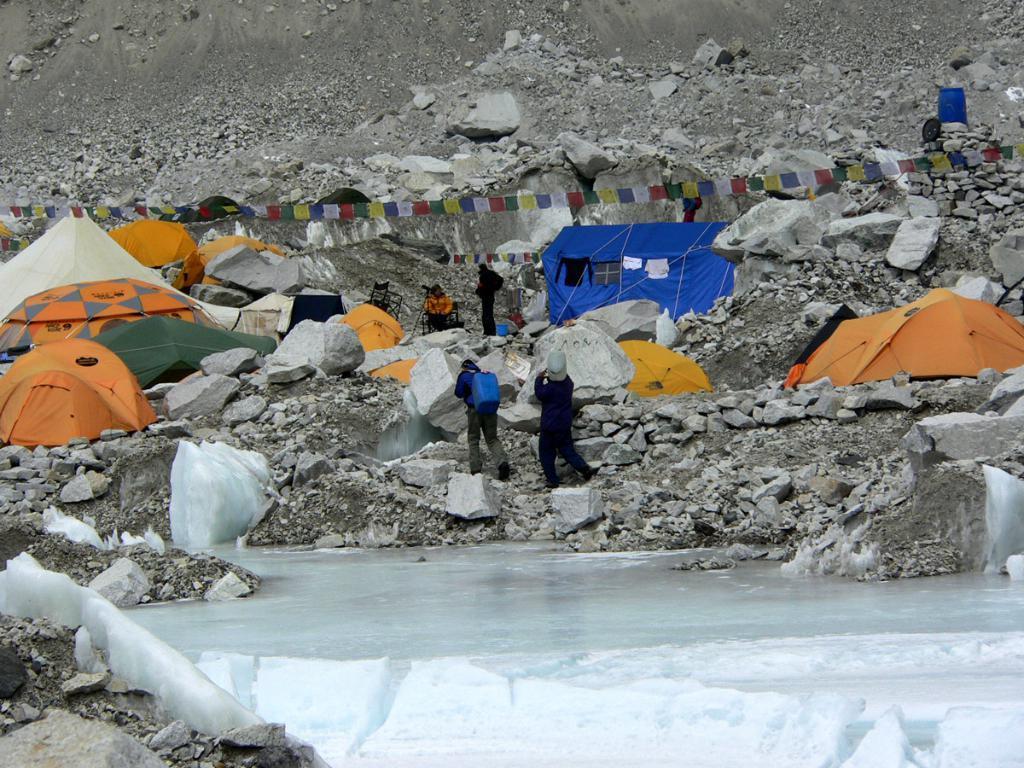Describe this image in one or two sentences. In this image at the bottom there is a small pond and snow, in the background there are some mountains and tents and some people are walking and some of them are standing. 